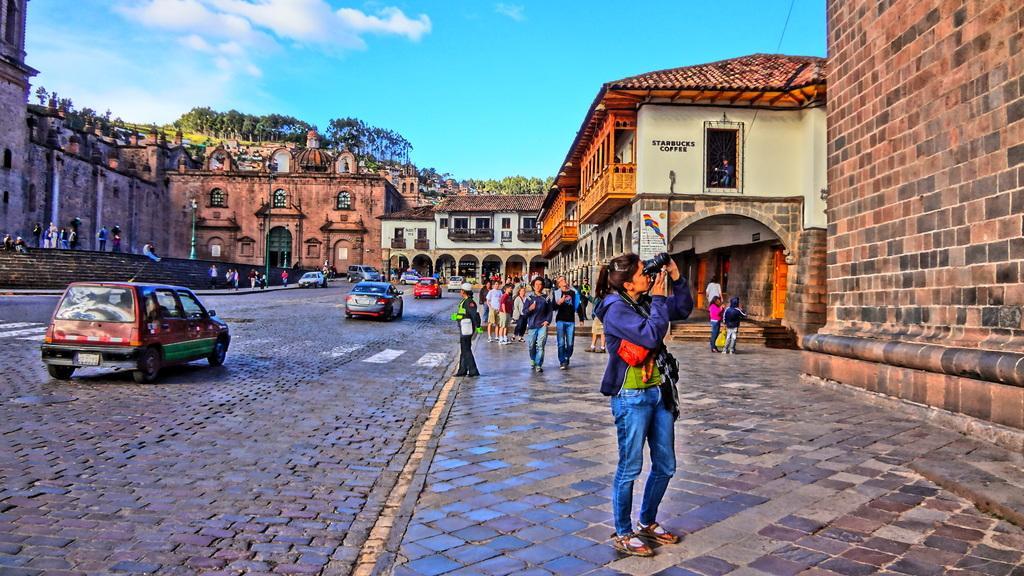Please provide a concise description of this image. In the foreground I can see fleets of vehicles and a crowd on the road. In the background, I can see buildings, steps, trees, plants, boards and the sky. This image is taken may be during a day. 